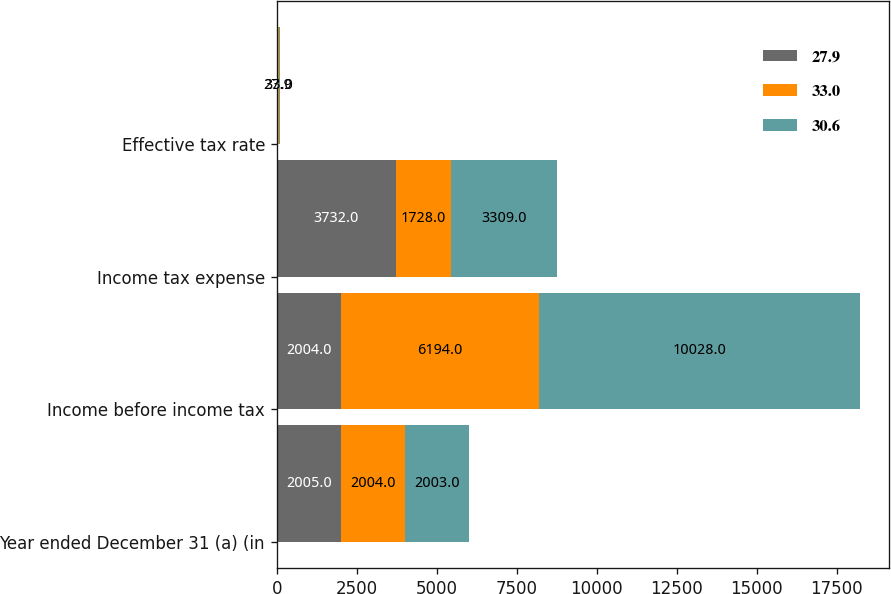<chart> <loc_0><loc_0><loc_500><loc_500><stacked_bar_chart><ecel><fcel>Year ended December 31 (a) (in<fcel>Income before income tax<fcel>Income tax expense<fcel>Effective tax rate<nl><fcel>27.9<fcel>2005<fcel>2004<fcel>3732<fcel>30.6<nl><fcel>33<fcel>2004<fcel>6194<fcel>1728<fcel>27.9<nl><fcel>30.6<fcel>2003<fcel>10028<fcel>3309<fcel>33<nl></chart> 